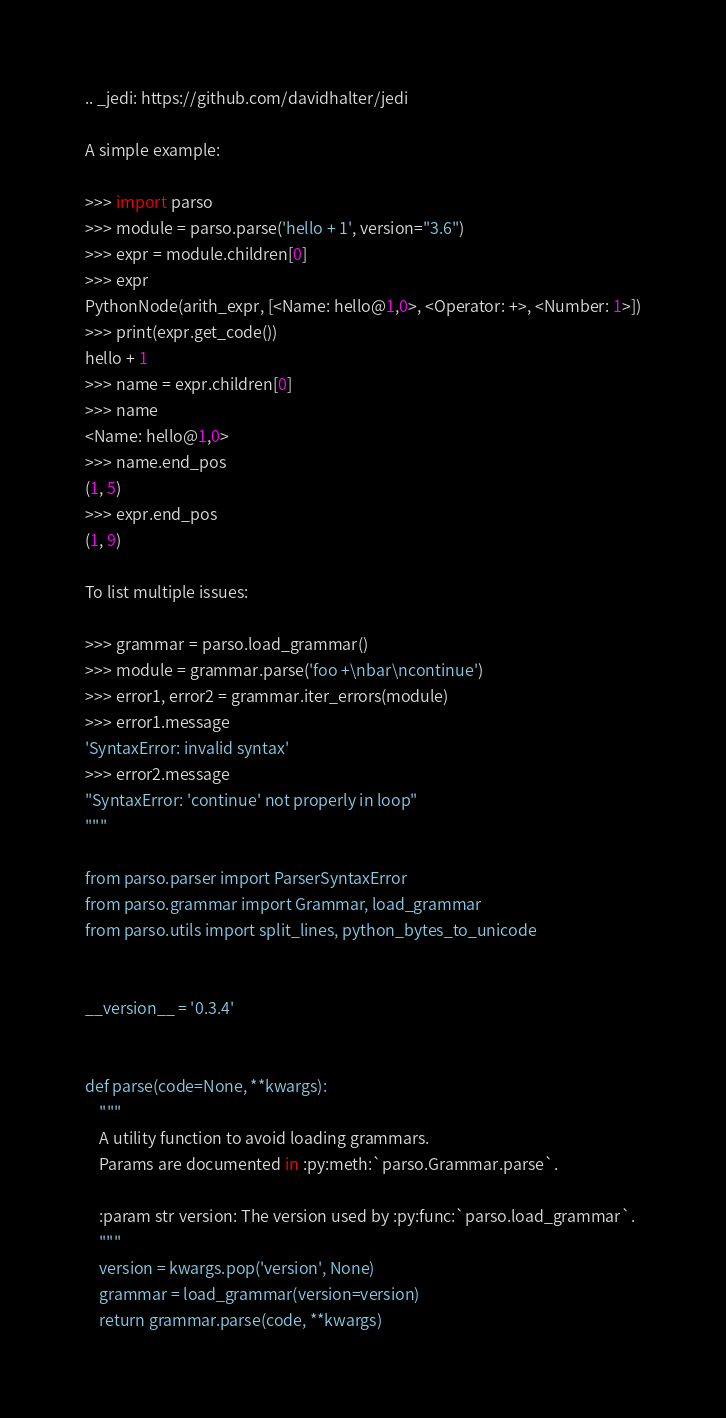Convert code to text. <code><loc_0><loc_0><loc_500><loc_500><_Python_>.. _jedi: https://github.com/davidhalter/jedi

A simple example:

>>> import parso
>>> module = parso.parse('hello + 1', version="3.6")
>>> expr = module.children[0]
>>> expr
PythonNode(arith_expr, [<Name: hello@1,0>, <Operator: +>, <Number: 1>])
>>> print(expr.get_code())
hello + 1
>>> name = expr.children[0]
>>> name
<Name: hello@1,0>
>>> name.end_pos
(1, 5)
>>> expr.end_pos
(1, 9)

To list multiple issues:

>>> grammar = parso.load_grammar()
>>> module = grammar.parse('foo +\nbar\ncontinue')
>>> error1, error2 = grammar.iter_errors(module)
>>> error1.message
'SyntaxError: invalid syntax'
>>> error2.message
"SyntaxError: 'continue' not properly in loop"
"""

from parso.parser import ParserSyntaxError
from parso.grammar import Grammar, load_grammar
from parso.utils import split_lines, python_bytes_to_unicode


__version__ = '0.3.4'


def parse(code=None, **kwargs):
    """
    A utility function to avoid loading grammars.
    Params are documented in :py:meth:`parso.Grammar.parse`.

    :param str version: The version used by :py:func:`parso.load_grammar`.
    """
    version = kwargs.pop('version', None)
    grammar = load_grammar(version=version)
    return grammar.parse(code, **kwargs)
</code> 